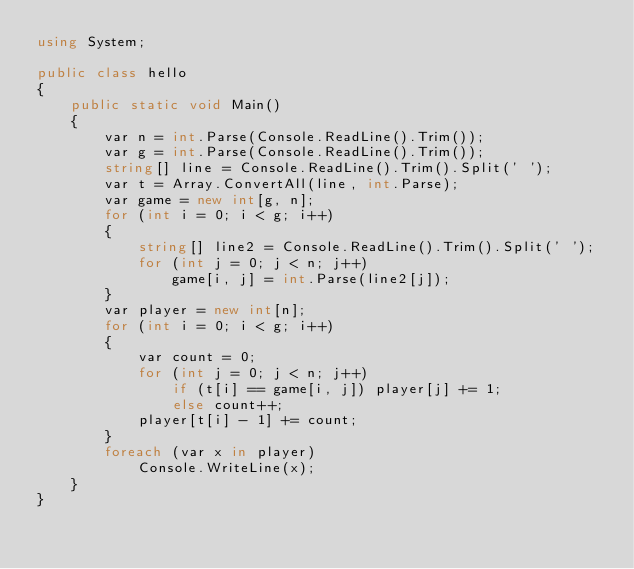<code> <loc_0><loc_0><loc_500><loc_500><_C#_>using System;

public class hello
{
    public static void Main()
    {
        var n = int.Parse(Console.ReadLine().Trim());
        var g = int.Parse(Console.ReadLine().Trim());
        string[] line = Console.ReadLine().Trim().Split(' ');
        var t = Array.ConvertAll(line, int.Parse);
        var game = new int[g, n];
        for (int i = 0; i < g; i++)
        {
            string[] line2 = Console.ReadLine().Trim().Split(' ');
            for (int j = 0; j < n; j++)
                game[i, j] = int.Parse(line2[j]);
        }
        var player = new int[n];
        for (int i = 0; i < g; i++)
        {
            var count = 0;
            for (int j = 0; j < n; j++)
                if (t[i] == game[i, j]) player[j] += 1;
                else count++;
            player[t[i] - 1] += count;
        }
        foreach (var x in player)
            Console.WriteLine(x);
    }
}</code> 